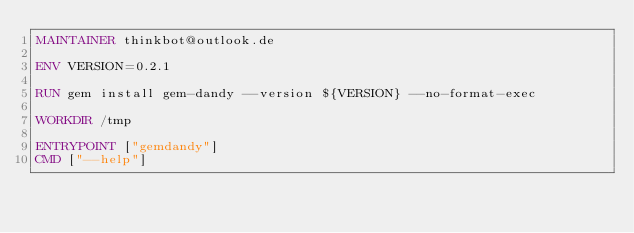<code> <loc_0><loc_0><loc_500><loc_500><_Dockerfile_>MAINTAINER thinkbot@outlook.de

ENV VERSION=0.2.1

RUN gem install gem-dandy --version ${VERSION} --no-format-exec

WORKDIR /tmp

ENTRYPOINT ["gemdandy"]
CMD ["--help"]
</code> 